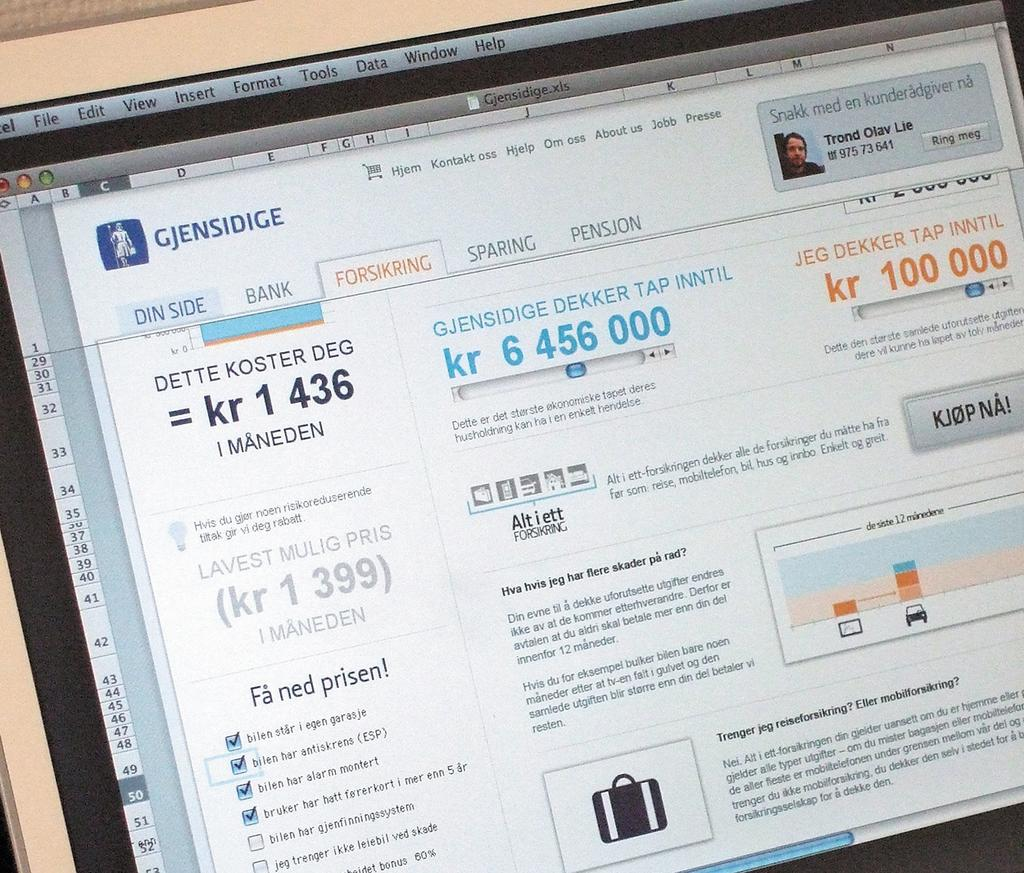Provide a one-sentence caption for the provided image. A customer has purchased a ticket on a site called Gjensidige. 